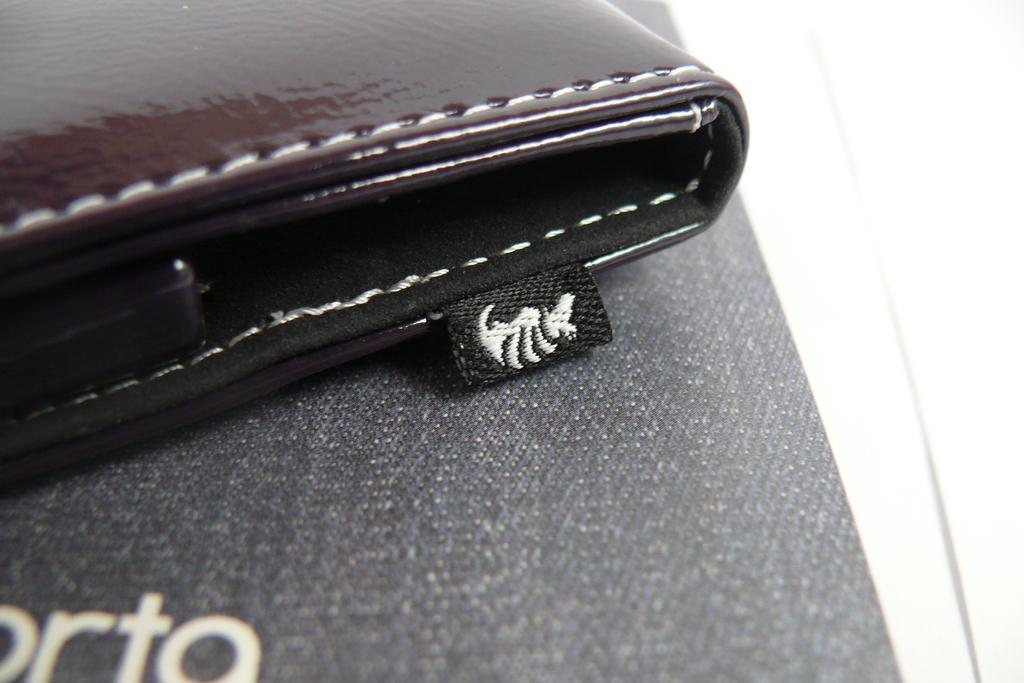What object can be seen in the image? There is a wallet in the image. Where is the wallet located in the image? The wallet is placed on a surface. What type of reaction can be seen from the ant in the image? There is no ant present in the image, so it is not possible to determine any reaction. 